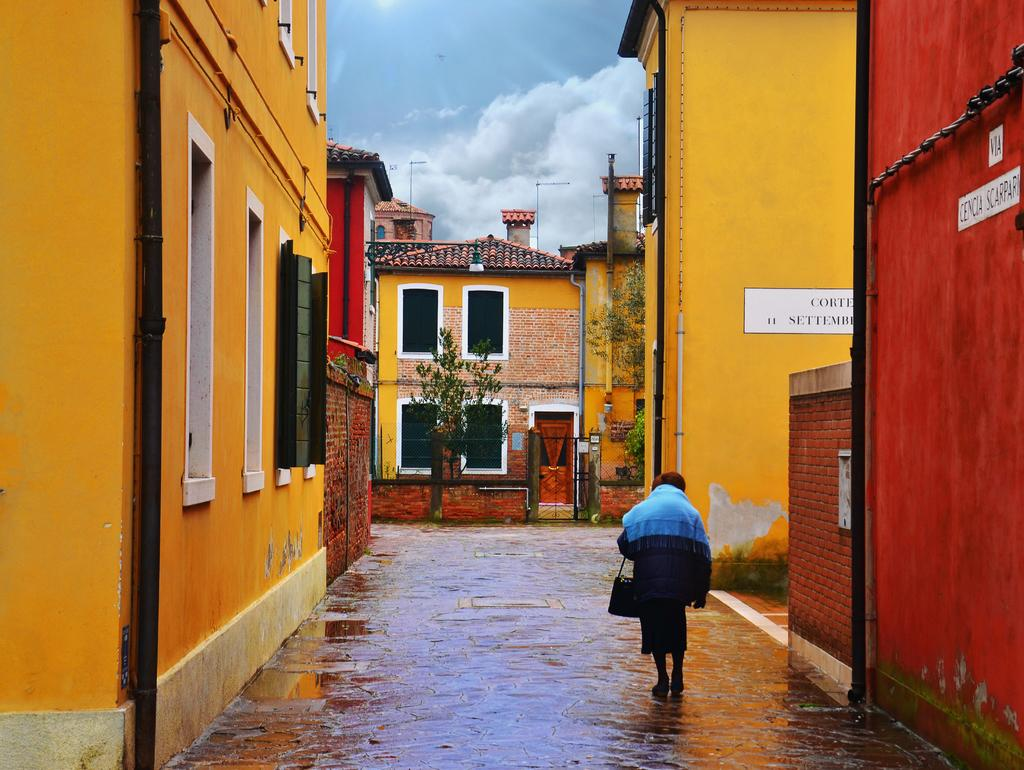What is the person in the image doing? There is a person walking on the road in the image. What can be seen in the background of the image? There are many buildings and trees in the image. What is visible in the sky in the image? The sky is visible in the image, and clouds are present. Can you see a pig sitting on a throne in the image? There is no pig or throne present in the image. 